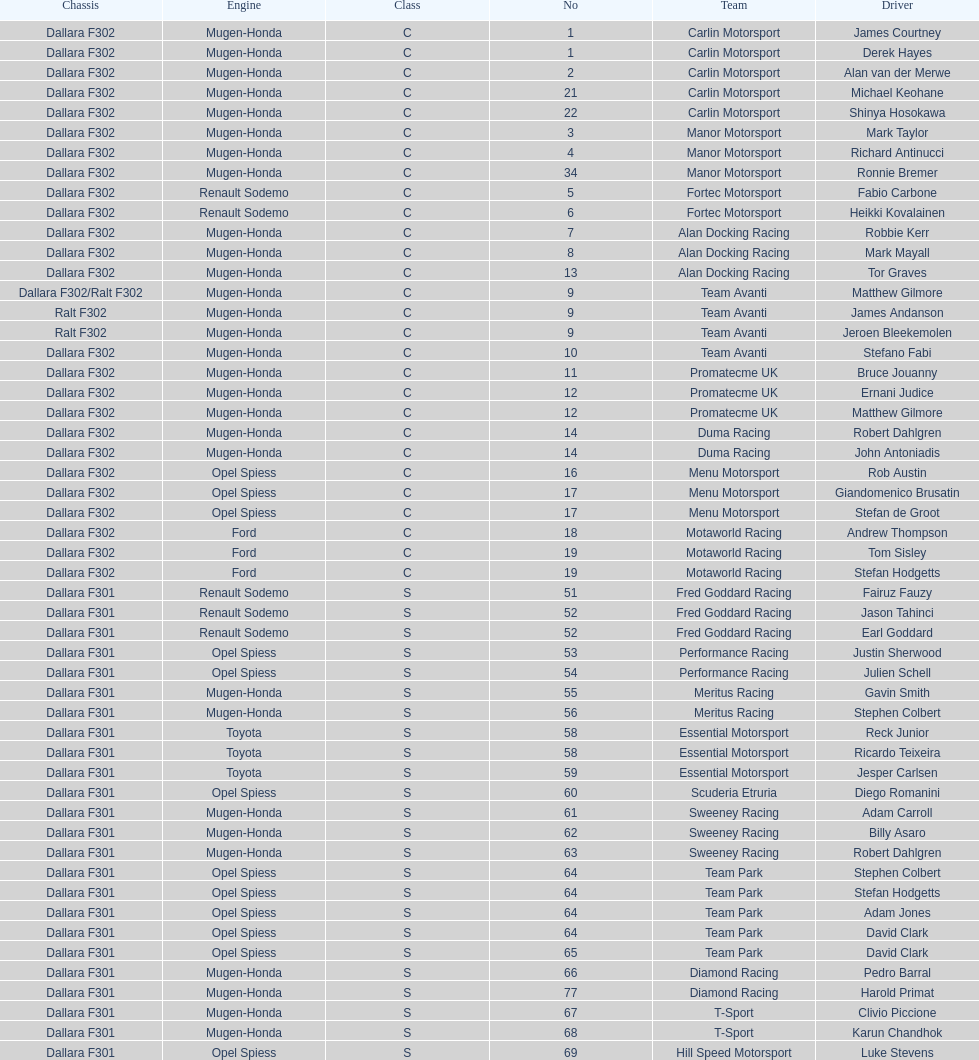How many class s (scholarship) teams are on the chart? 19. 